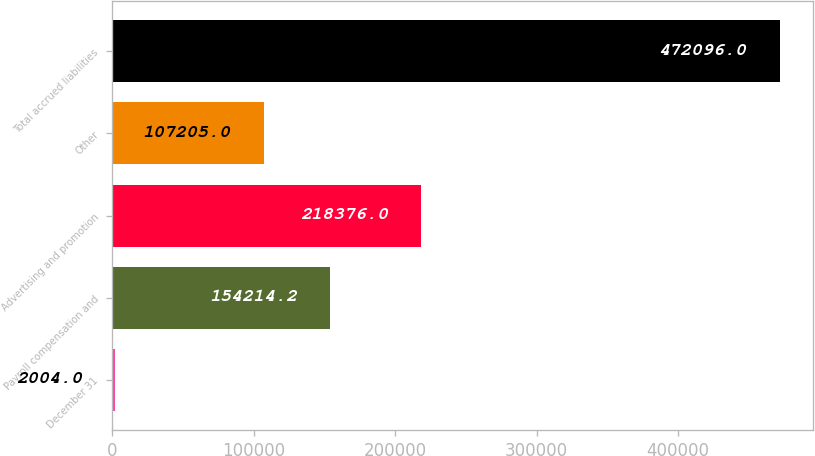Convert chart. <chart><loc_0><loc_0><loc_500><loc_500><bar_chart><fcel>December 31<fcel>Payroll compensation and<fcel>Advertising and promotion<fcel>Other<fcel>Total accrued liabilities<nl><fcel>2004<fcel>154214<fcel>218376<fcel>107205<fcel>472096<nl></chart> 